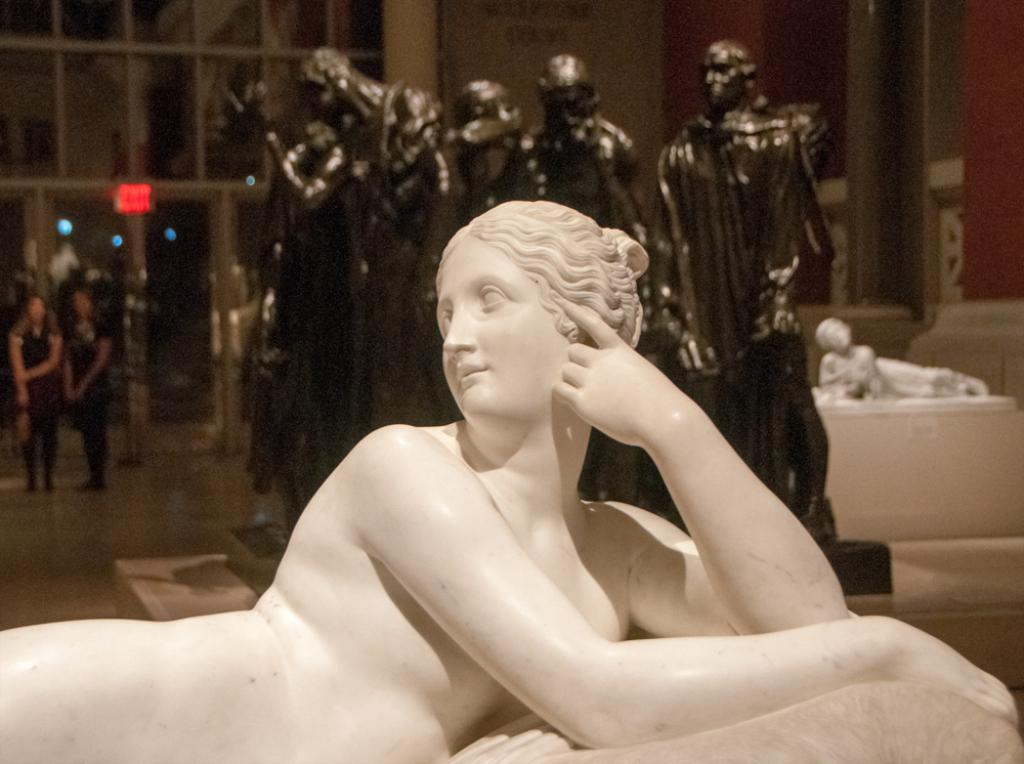What can be seen in the image that represents art or design? There are sculptures in the image. How many people are inside the building in the image? There are two people inside the building in the image. What is attached to the glass door in the image? There is a sign board attached to a glass door in the image. What type of trees can be seen through the glass door in the image? There are no trees visible through the glass door in the image; it only shows a sign board attached to the door. What is the taste of the sculptures in the image? Sculptures are not edible and therefore do not have a taste. 